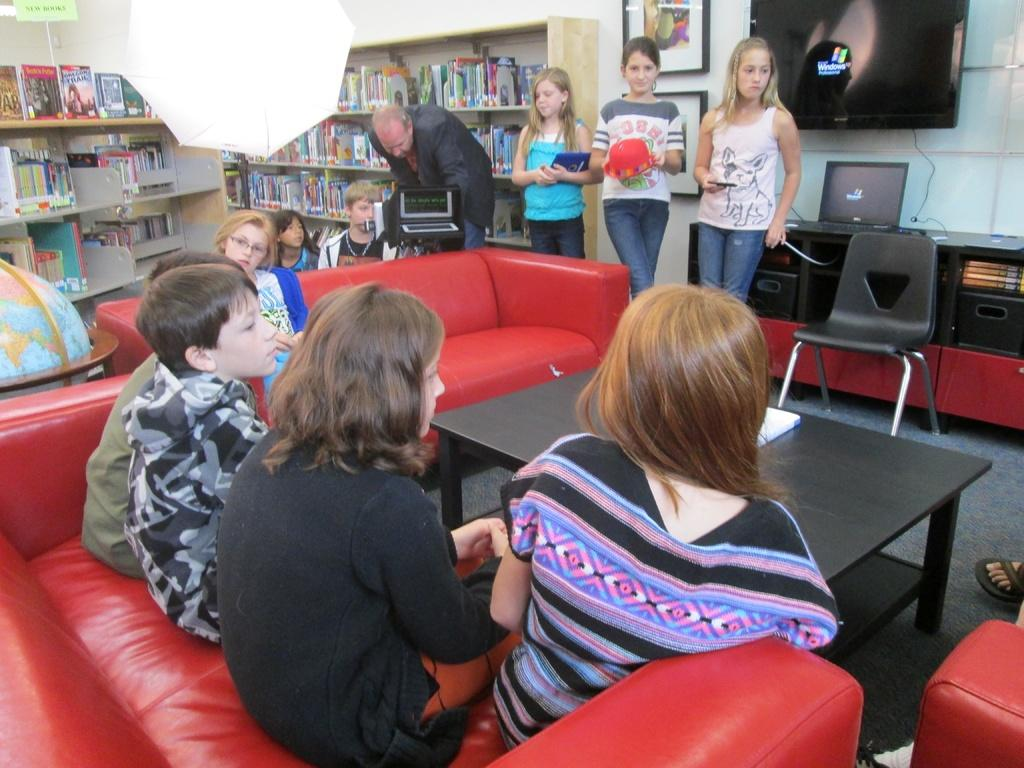<image>
Share a concise interpretation of the image provided. Three kids stand in front of a large monitor that shows the windows xp logo. 